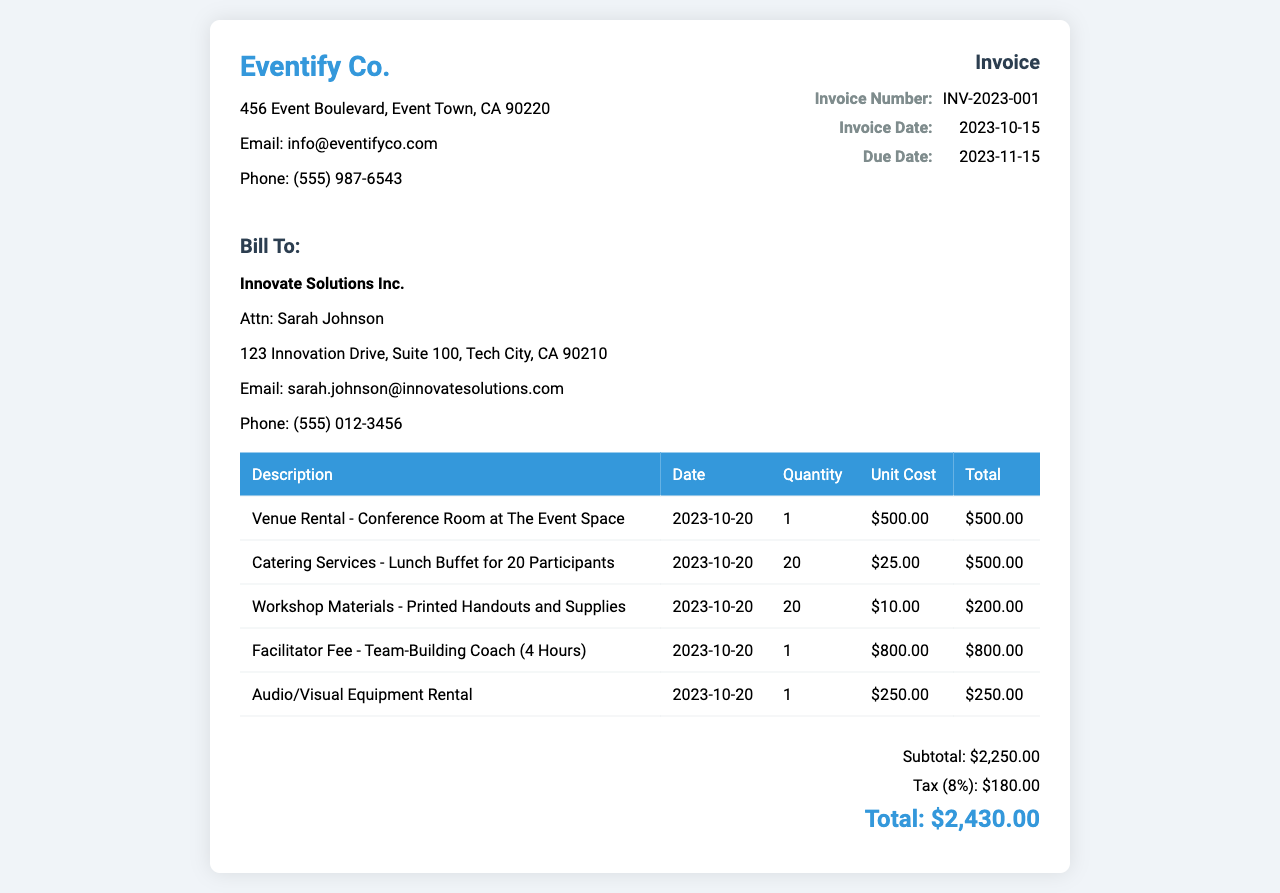What is the invoice number? The invoice number is a unique identifier for this invoice, listed in the details section.
Answer: INV-2023-001 What is the total cost for catering services? The total cost for catering services is found in the table under the catering entry, which lists the unit cost multiplied by the quantity.
Answer: $500.00 What is the venue for the workshop? The venue is specified in the description of the venue rental at the top of the table.
Answer: The Event Space What is the due date for the invoice? The due date is located in the invoice details section.
Answer: 2023-11-15 How much is the tax calculated in the invoice? The tax amount is mentioned in the summary section as a percentage of the subtotal.
Answer: $180.00 What is the subtotal amount before tax? The subtotal is explicitly listed in the summary section before tax is applied.
Answer: $2,250.00 When will the team-building workshop take place? The date for the workshop is indicated in the date column of the venue rental entry.
Answer: 2023-10-20 Who is the contact person for billing? The contact person for billing is identified in the "Bill To" section of the invoice.
Answer: Sarah Johnson How many participants are included in the catering services? The number of participants for the catering services is indicated in the catering services description.
Answer: 20 